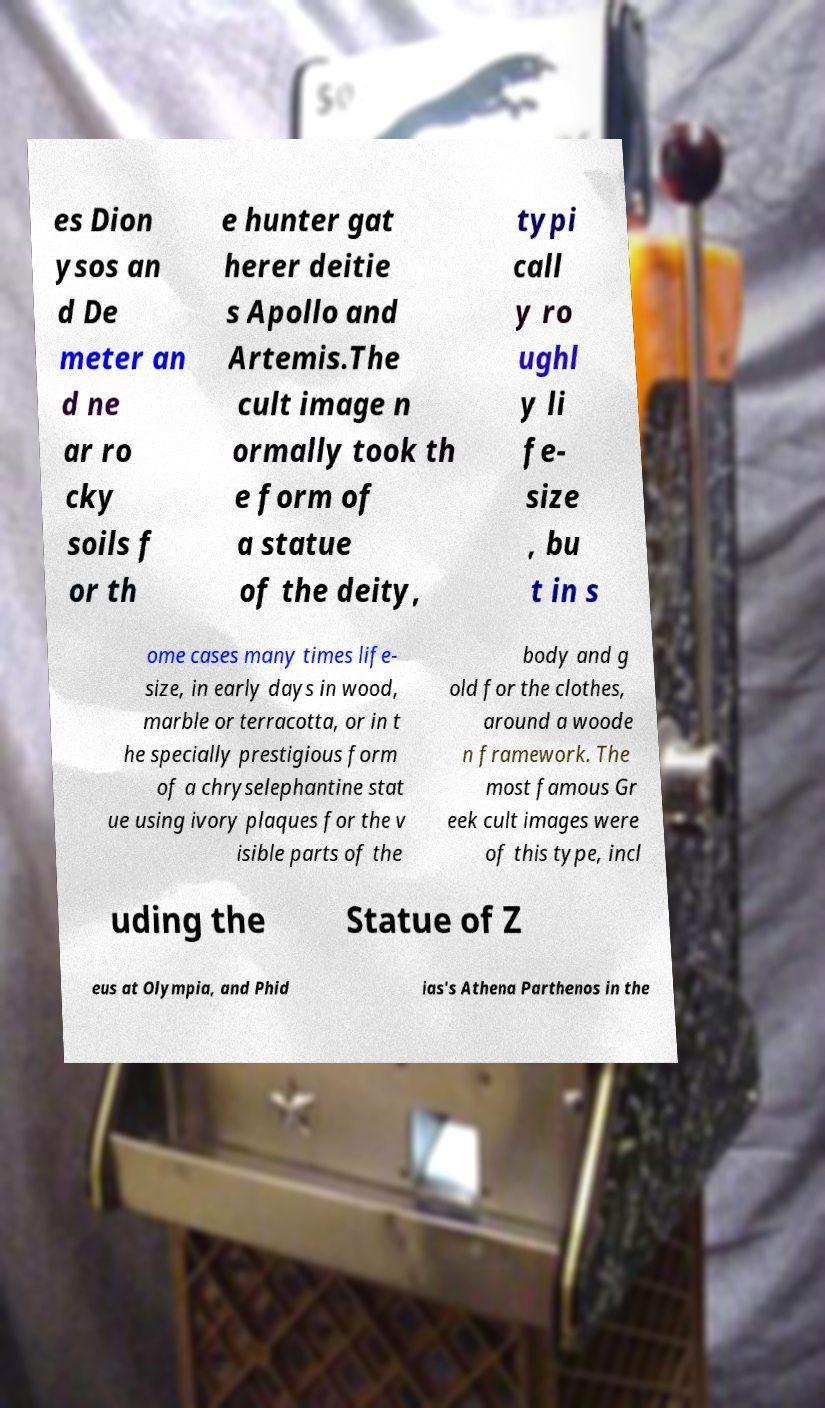Could you extract and type out the text from this image? es Dion ysos an d De meter an d ne ar ro cky soils f or th e hunter gat herer deitie s Apollo and Artemis.The cult image n ormally took th e form of a statue of the deity, typi call y ro ughl y li fe- size , bu t in s ome cases many times life- size, in early days in wood, marble or terracotta, or in t he specially prestigious form of a chryselephantine stat ue using ivory plaques for the v isible parts of the body and g old for the clothes, around a woode n framework. The most famous Gr eek cult images were of this type, incl uding the Statue of Z eus at Olympia, and Phid ias's Athena Parthenos in the 